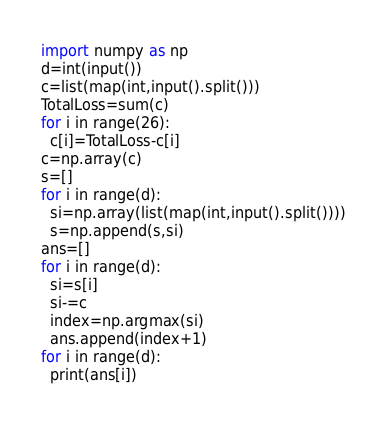Convert code to text. <code><loc_0><loc_0><loc_500><loc_500><_Python_>import numpy as np
d=int(input())
c=list(map(int,input().split()))
TotalLoss=sum(c)
for i in range(26):
  c[i]=TotalLoss-c[i]
c=np.array(c)
s=[]
for i in range(d):
  si=np.array(list(map(int,input().split())))
  s=np.append(s,si)
ans=[]
for i in range(d):
  si=s[i]
  si-=c
  index=np.argmax(si)
  ans.append(index+1)
for i in range(d):
  print(ans[i])</code> 